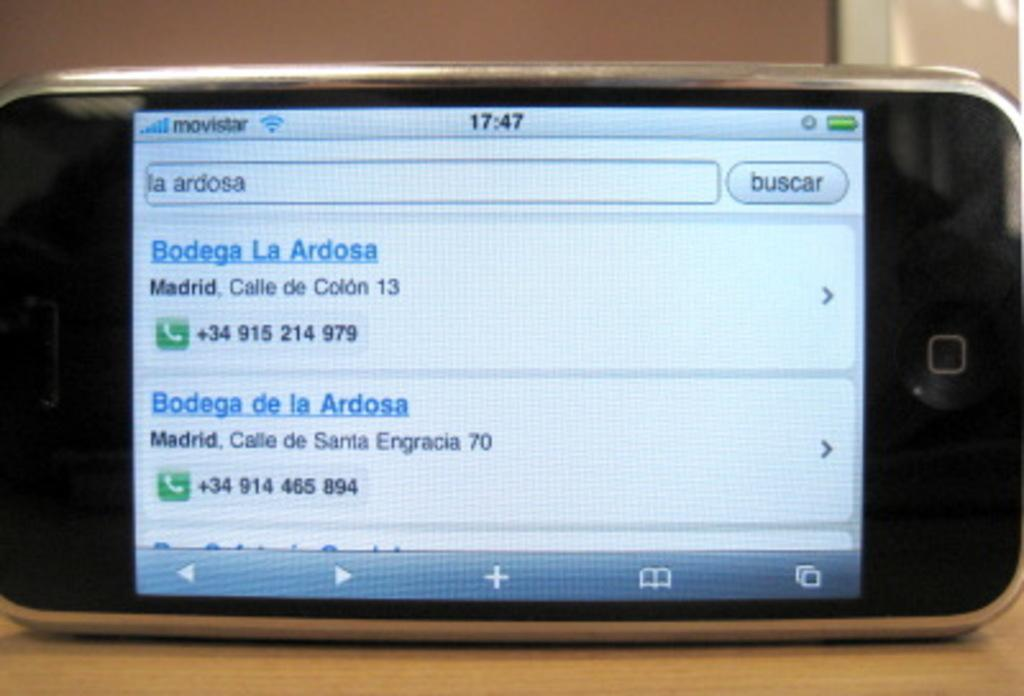What object is on the table in the image? There is a cell phone on the table in the image. What is the cell phone displaying on its screen? The cell phone screen shows text and icons. What can be seen in the background of the image? There is a wall visible in the background of the image. What type of dress is the cell phone wearing in the image? The cell phone is an inanimate object and does not wear clothing, including dresses. 